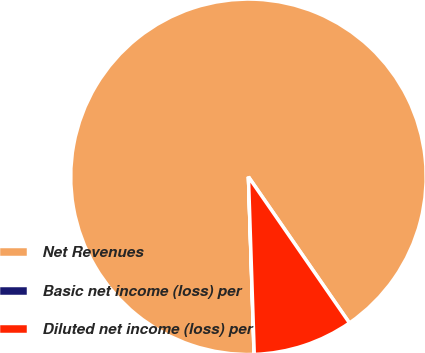Convert chart. <chart><loc_0><loc_0><loc_500><loc_500><pie_chart><fcel>Net Revenues<fcel>Basic net income (loss) per<fcel>Diluted net income (loss) per<nl><fcel>90.88%<fcel>0.02%<fcel>9.1%<nl></chart> 